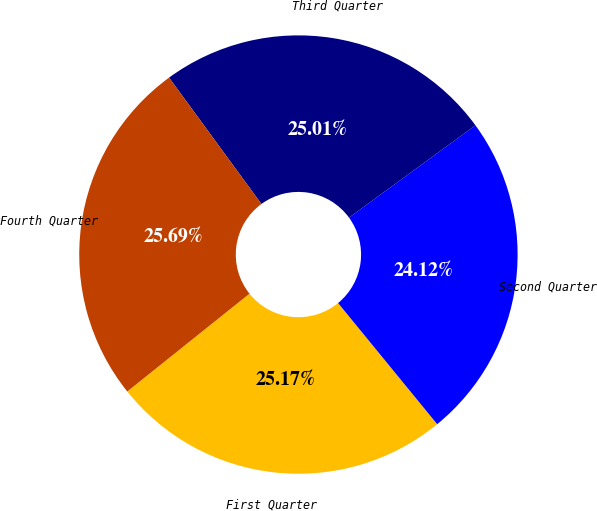Convert chart to OTSL. <chart><loc_0><loc_0><loc_500><loc_500><pie_chart><fcel>First Quarter<fcel>Second Quarter<fcel>Third Quarter<fcel>Fourth Quarter<nl><fcel>25.17%<fcel>24.12%<fcel>25.01%<fcel>25.69%<nl></chart> 